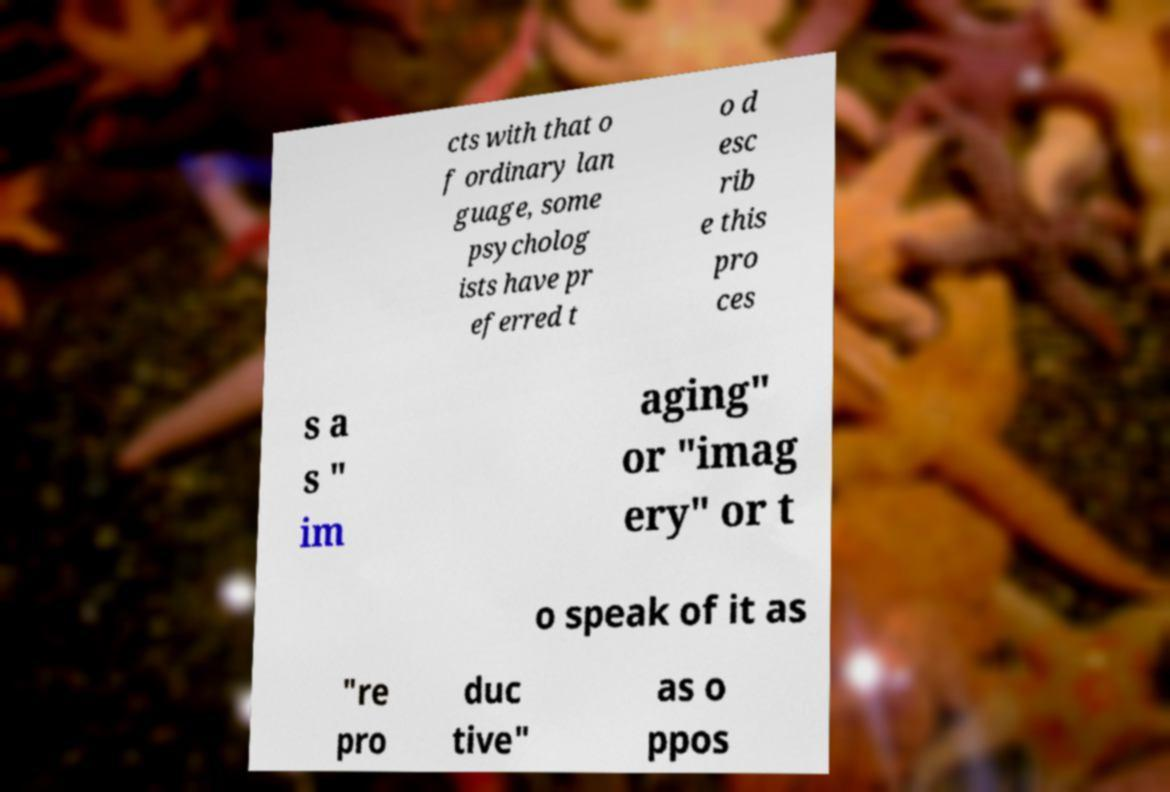I need the written content from this picture converted into text. Can you do that? cts with that o f ordinary lan guage, some psycholog ists have pr eferred t o d esc rib e this pro ces s a s " im aging" or "imag ery" or t o speak of it as "re pro duc tive" as o ppos 